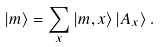Convert formula to latex. <formula><loc_0><loc_0><loc_500><loc_500>\left | { m } \right \rangle = \sum _ { x } \left | { m } , { x } \right \rangle \left | A _ { x } \right \rangle .</formula> 